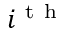Convert formula to latex. <formula><loc_0><loc_0><loc_500><loc_500>i ^ { t h }</formula> 